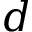<formula> <loc_0><loc_0><loc_500><loc_500>d</formula> 